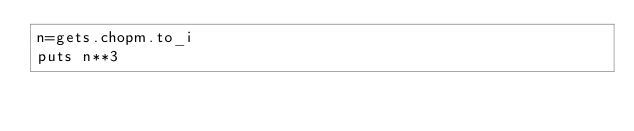<code> <loc_0><loc_0><loc_500><loc_500><_Ruby_>n=gets.chopm.to_i
puts n**3</code> 